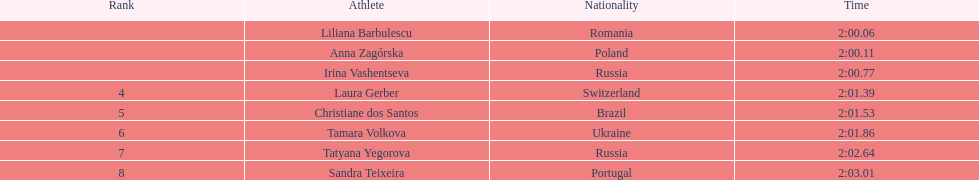Write the full table. {'header': ['Rank', 'Athlete', 'Nationality', 'Time'], 'rows': [['', 'Liliana Barbulescu', 'Romania', '2:00.06'], ['', 'Anna Zagórska', 'Poland', '2:00.11'], ['', 'Irina Vashentseva', 'Russia', '2:00.77'], ['4', 'Laura Gerber', 'Switzerland', '2:01.39'], ['5', 'Christiane dos Santos', 'Brazil', '2:01.53'], ['6', 'Tamara Volkova', 'Ukraine', '2:01.86'], ['7', 'Tatyana Yegorova', 'Russia', '2:02.64'], ['8', 'Sandra Teixeira', 'Portugal', '2:03.01']]} What is the name of the highest-ranked finalist in this semifinals round? Liliana Barbulescu. 